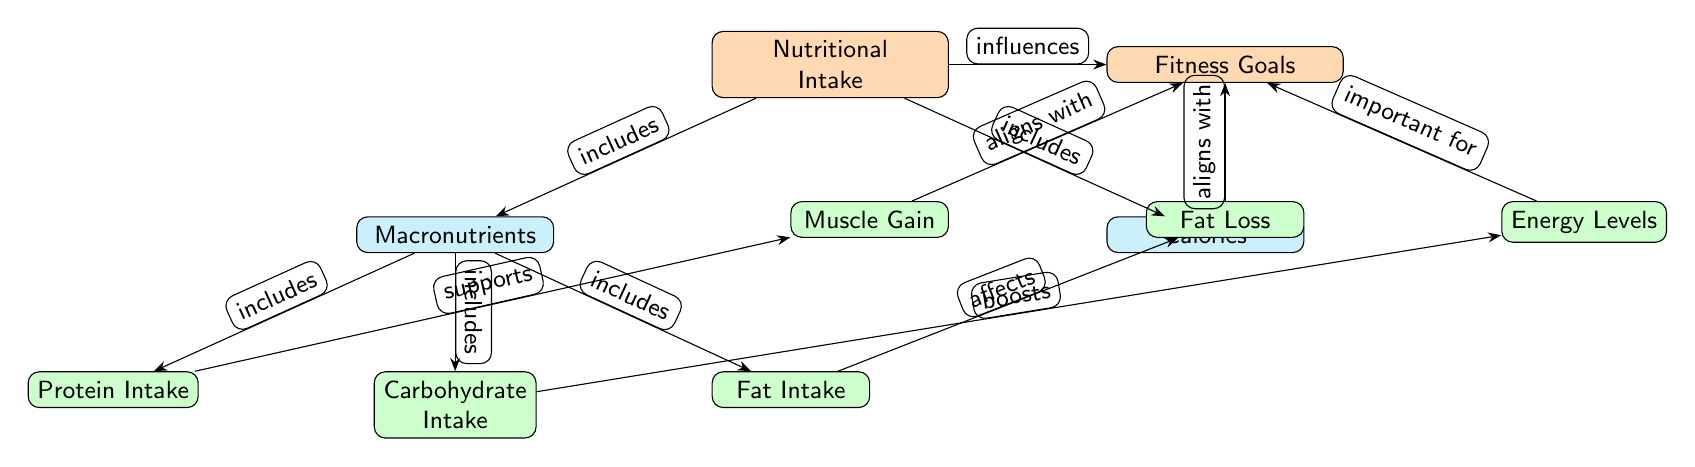What are the two main categories under Nutritional Intake? The diagram shows that Nutritional Intake is broken down into two main categories: Macronutrients and Calories.
Answer: Macronutrients, Calories How many leaf nodes are connected to the Macronutrients node? The diagram reveals that the Macronutrients node has three leaf nodes connected to it: Protein Intake, Carbohydrate Intake, and Fat Intake. Therefore, there are three leaf nodes.
Answer: 3 Which fitness goal is supported by Protein Intake? The diagram indicates a direct connection between Protein Intake and Muscle Gain, stating that Protein Intake supports Muscle Gain.
Answer: Muscle Gain What does Carbohydrate Intake boost? According to the diagram, Carbohydrate Intake boosts Energy Levels, showing a direct influence from Carbohydrate Intake to Energy Levels.
Answer: Energy Levels What is the relationship between Fat Intake and Fat Loss? The diagram explicitly states that Fat Intake affects Fat Loss, indicating a direct influence from Fat Intake to Fat Loss.
Answer: affects Which node aligns with both Muscle Gain and Fat Loss? The Fitness Goals node receives alignment from both Muscle Gain and Fat Loss, as shown by the connections leading to the Fitness Goals node.
Answer: Fitness Goals What influences Fitness Goals according to the diagram? The diagram clearly shows that Nutritional Intake influences Fitness Goals, establishing a direct connection from Nutritional Intake to Fitness Goals.
Answer: Nutritional Intake Which macronutrient is directly related to Protein Intake? The diagram indicates that Protein Intake falls under the Macronutrients category, making it the directly related macronutrient.
Answer: Macronutrients What edge type is used to describe the connection from Fat Intake to Fat Loss? The diagram describes the connection from Fat Intake to Fat Loss using the edge type "affects," demonstrating the influence of Fat Intake on Fat Loss.
Answer: affects 